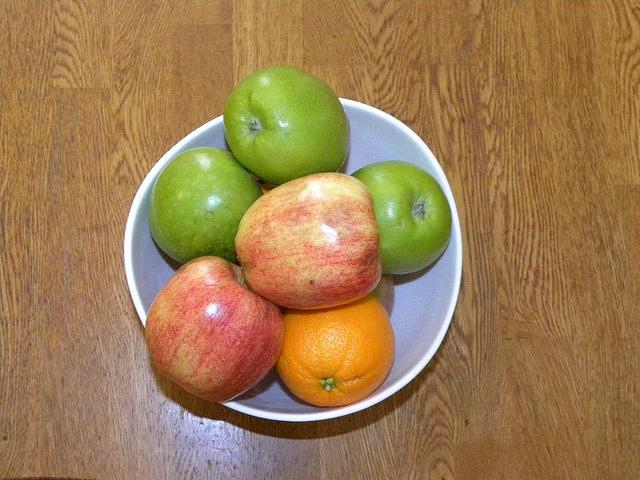What is the apple sitting on?
Give a very brief answer. Bowl. How many of the apples are peeled?
Write a very short answer. 0. How many apples are pictured?
Short answer required. 5. How many apples have been cut up?
Give a very brief answer. 0. Which fruit doesn't match the others?
Short answer required. Orange. How many different kinds of apples are in the bowl?
Give a very brief answer. 2. 